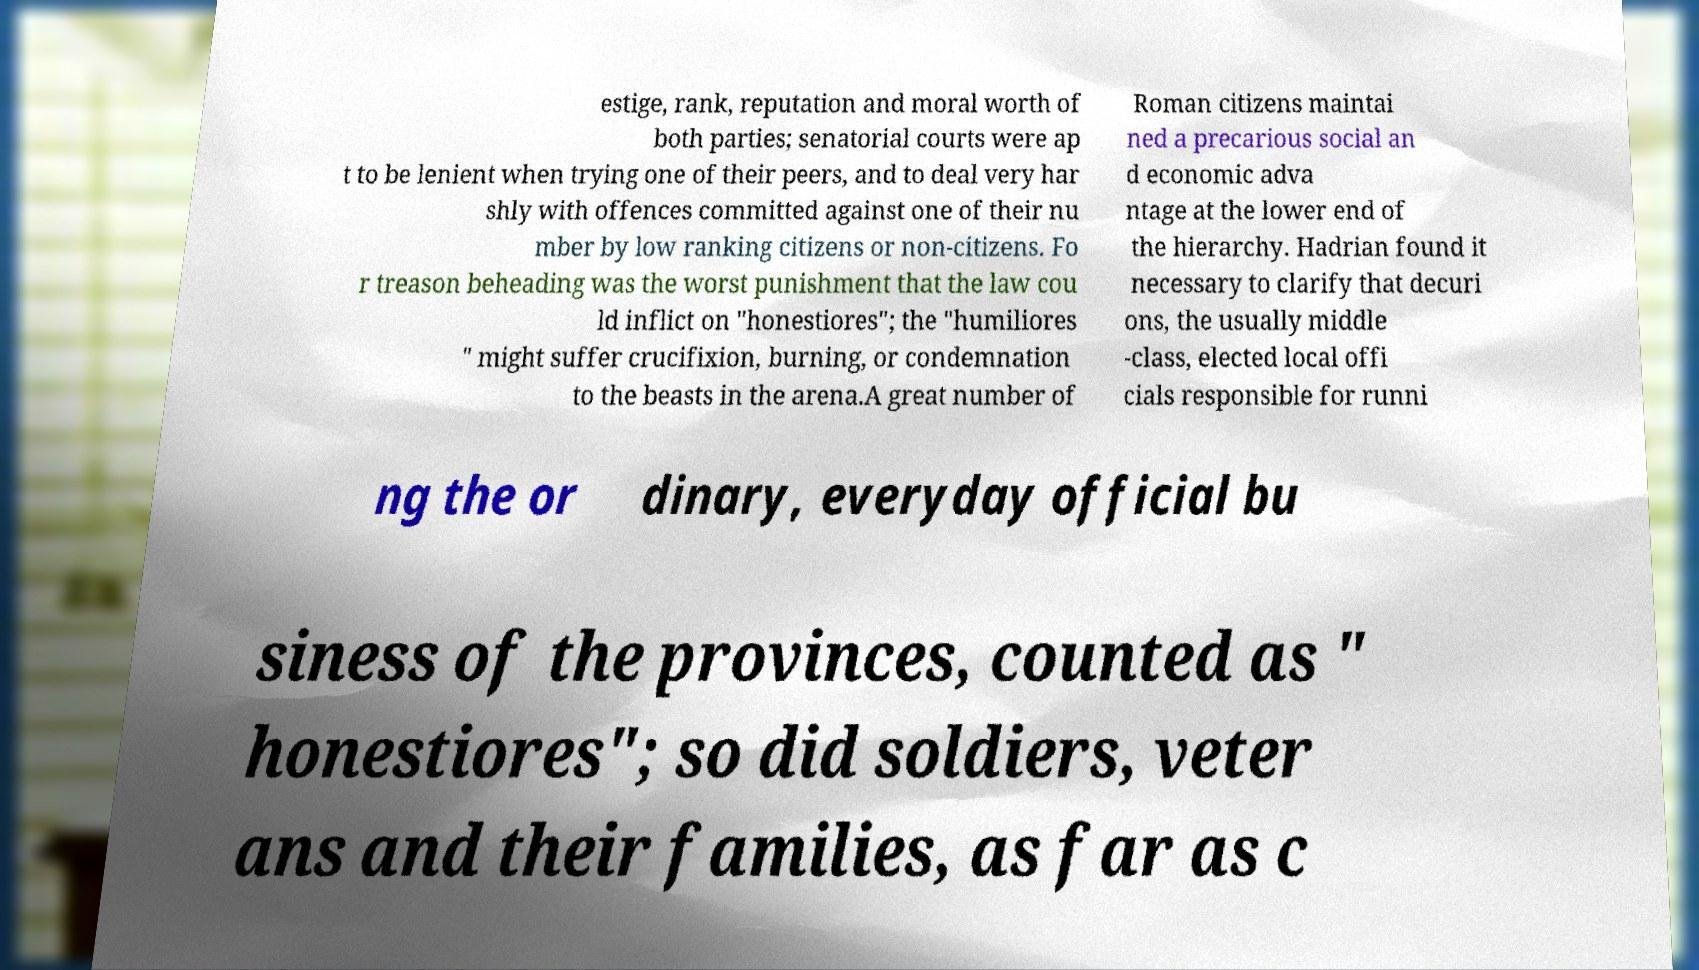Please identify and transcribe the text found in this image. estige, rank, reputation and moral worth of both parties; senatorial courts were ap t to be lenient when trying one of their peers, and to deal very har shly with offences committed against one of their nu mber by low ranking citizens or non-citizens. Fo r treason beheading was the worst punishment that the law cou ld inflict on "honestiores"; the "humiliores " might suffer crucifixion, burning, or condemnation to the beasts in the arena.A great number of Roman citizens maintai ned a precarious social an d economic adva ntage at the lower end of the hierarchy. Hadrian found it necessary to clarify that decuri ons, the usually middle -class, elected local offi cials responsible for runni ng the or dinary, everyday official bu siness of the provinces, counted as " honestiores"; so did soldiers, veter ans and their families, as far as c 